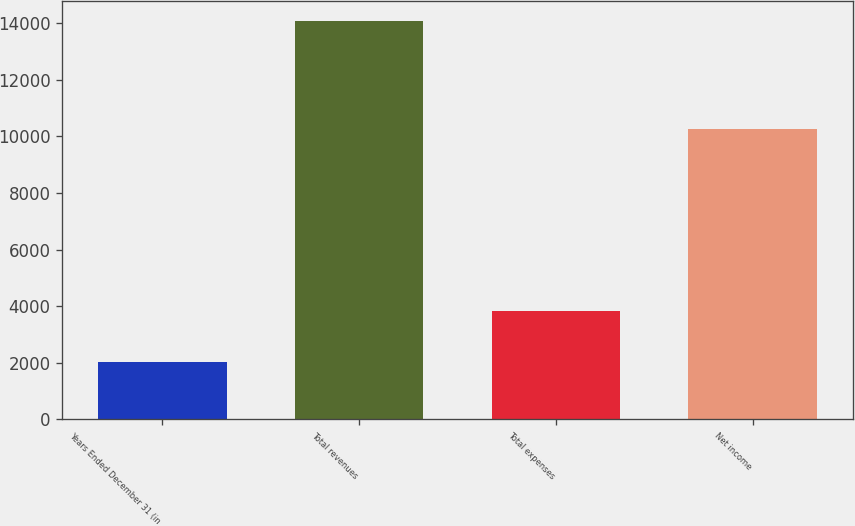Convert chart to OTSL. <chart><loc_0><loc_0><loc_500><loc_500><bar_chart><fcel>Years Ended December 31 (in<fcel>Total revenues<fcel>Total expenses<fcel>Net income<nl><fcel>2010<fcel>14079<fcel>3812<fcel>10267<nl></chart> 